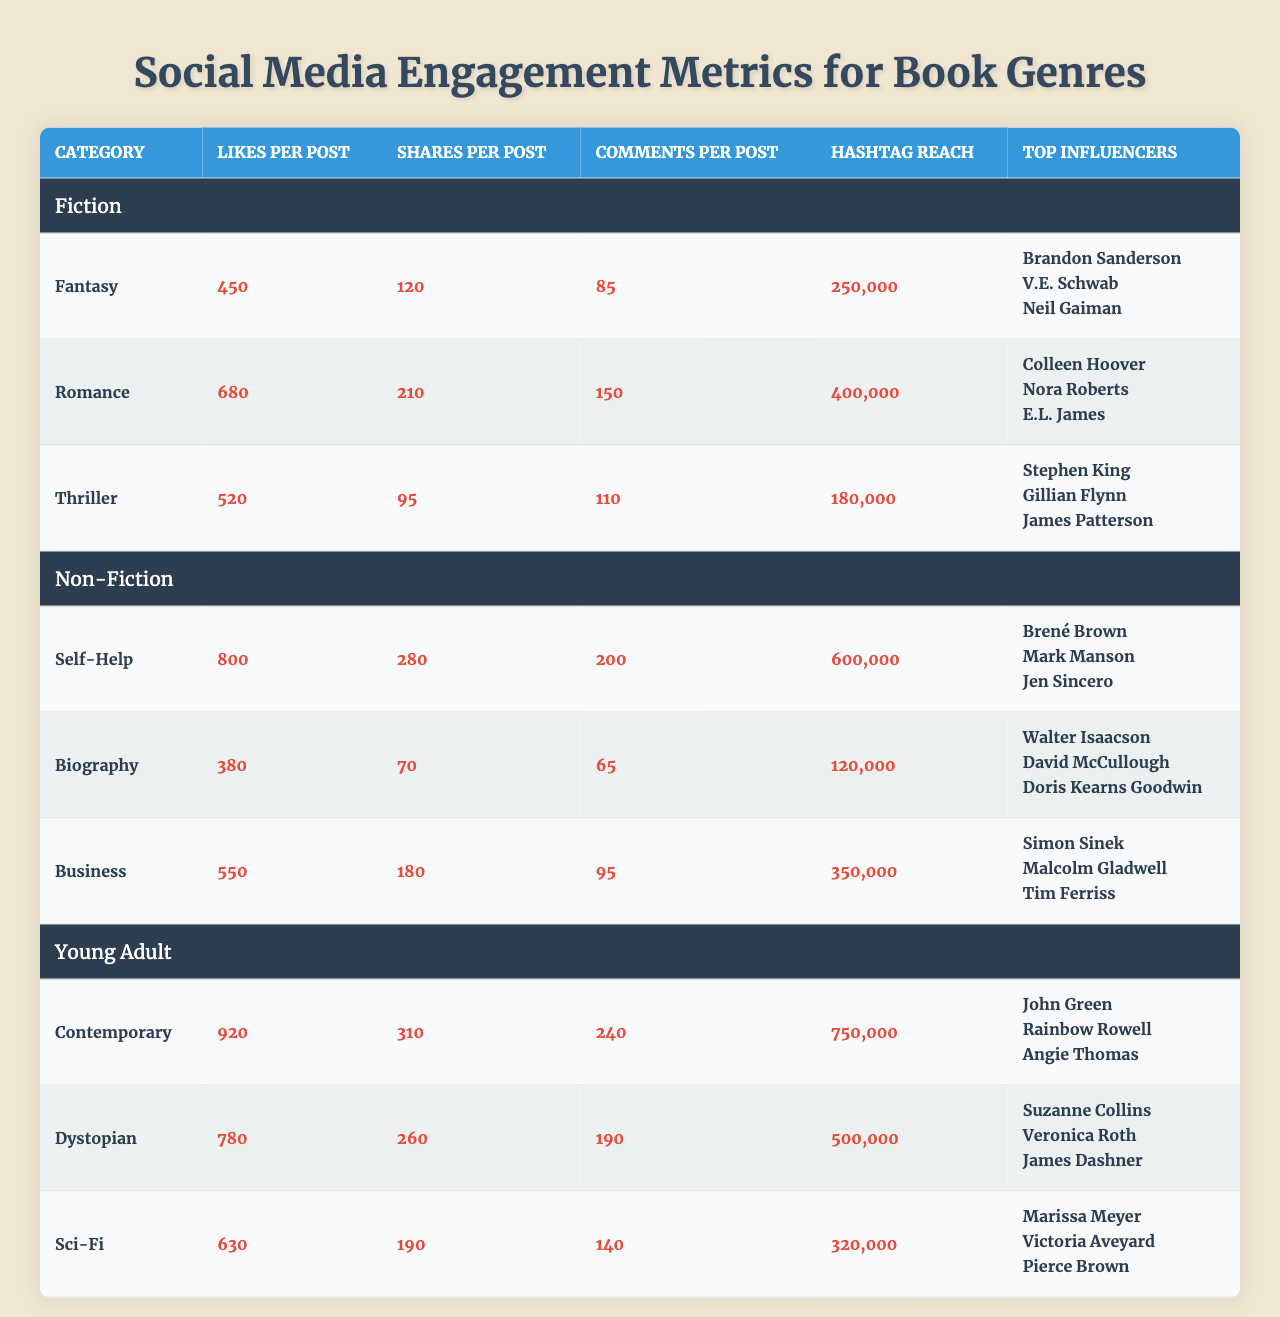What is the genre with the highest likes per post? Looking at the table, the 'Contemporary' genre under 'Young Adult' has the highest likes per post at 920.
Answer: Contemporary Which book genre generates the most comments per post? The 'Contemporary' genre in 'Young Adult' has the highest comments per post with a total of 240 comments.
Answer: Contemporary How many shares does the Romance genre receive per post? The table indicates the 'Romance' genre receives 210 shares per post.
Answer: 210 Is the likes per post for the Self-Help genre greater than that for Biography? The Self-Help genre has 800 likes per post while the Biography genre has 380 likes, thus making it true that Self-Help has more likes.
Answer: Yes What is the total hashtag reach for the Fantasy and Thriller genres combined? The Fantasy genre has a hashtag reach of 250,000 and the Thriller genre has 180,000. Adding them gives 250,000 + 180,000 = 430,000.
Answer: 430,000 Which genre has the lowest shares per post among fiction books? By examining the shares per post for Fiction genres, 'Thriller' has the lowest at 95 shares.
Answer: Thriller What is the average likes per post for Non-Fiction genres? To find the average, sum the likes per post: 800 (Self-Help) + 380 (Biography) + 550 (Business) = 1,730. Then divide by 3: 1,730 / 3 = 576.67.
Answer: 576.67 Which group has the highest overall hashtag reach and what is that number? The Young Adult group has the highest hashtag reach with 750,000 from the 'Contemporary' genre.
Answer: 750,000 Is it true that the Thriller genre's shares per post are significantly lower than those of the Romance genre? The Thriller genre has 95 shares while the Romance genre has 210 shares. Since 95 is less than 210, this statement is true.
Answer: Yes What is the difference in comments per post between Self-Help and Sci-Fi genres? The Self-Help genre has 200 comments per post and Sci-Fi has 140. The difference is 200 - 140 = 60 comments.
Answer: 60 